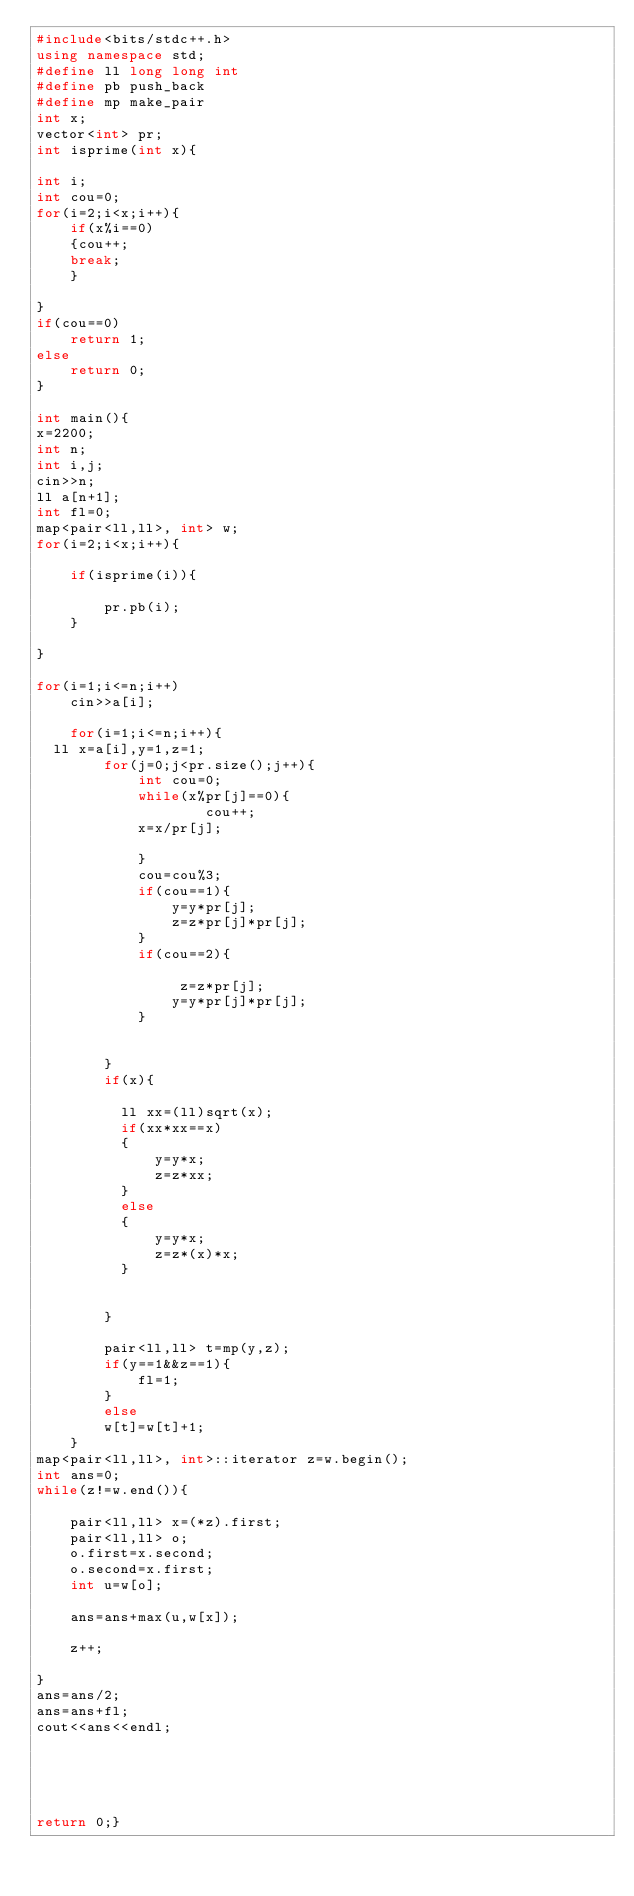<code> <loc_0><loc_0><loc_500><loc_500><_C++_>#include<bits/stdc++.h>
using namespace std;
#define ll long long int
#define pb push_back
#define mp make_pair
int x;
vector<int> pr;
int isprime(int x){

int i;
int cou=0;
for(i=2;i<x;i++){
    if(x%i==0)
    {cou++;
    break;
    }

}
if(cou==0)
    return 1;
else
    return 0;
}

int main(){
x=2200;
int n;
int i,j;
cin>>n;
ll a[n+1];
int fl=0;
map<pair<ll,ll>, int> w;
for(i=2;i<x;i++){

    if(isprime(i)){

        pr.pb(i);
    }

}

for(i=1;i<=n;i++)
    cin>>a[i];

    for(i=1;i<=n;i++){
  ll x=a[i],y=1,z=1;
        for(j=0;j<pr.size();j++){
            int cou=0;
            while(x%pr[j]==0){
                    cou++;
            x=x/pr[j];

            }
            cou=cou%3;
            if(cou==1){
                y=y*pr[j];
                z=z*pr[j]*pr[j];
            }
            if(cou==2){

                 z=z*pr[j];
                y=y*pr[j]*pr[j];
            }


        }
        if(x){

          ll xx=(ll)sqrt(x);
          if(xx*xx==x)
          {
              y=y*x;
              z=z*xx;
          }
          else
          {
              y=y*x;
              z=z*(x)*x;
          }


        }

        pair<ll,ll> t=mp(y,z);
        if(y==1&&z==1){
            fl=1;
        }
        else
        w[t]=w[t]+1;
    }
map<pair<ll,ll>, int>::iterator z=w.begin();
int ans=0;
while(z!=w.end()){

    pair<ll,ll> x=(*z).first;
    pair<ll,ll> o;
    o.first=x.second;
    o.second=x.first;
    int u=w[o];

    ans=ans+max(u,w[x]);

    z++;

}
ans=ans/2;
ans=ans+fl;
cout<<ans<<endl;





return 0;}
</code> 